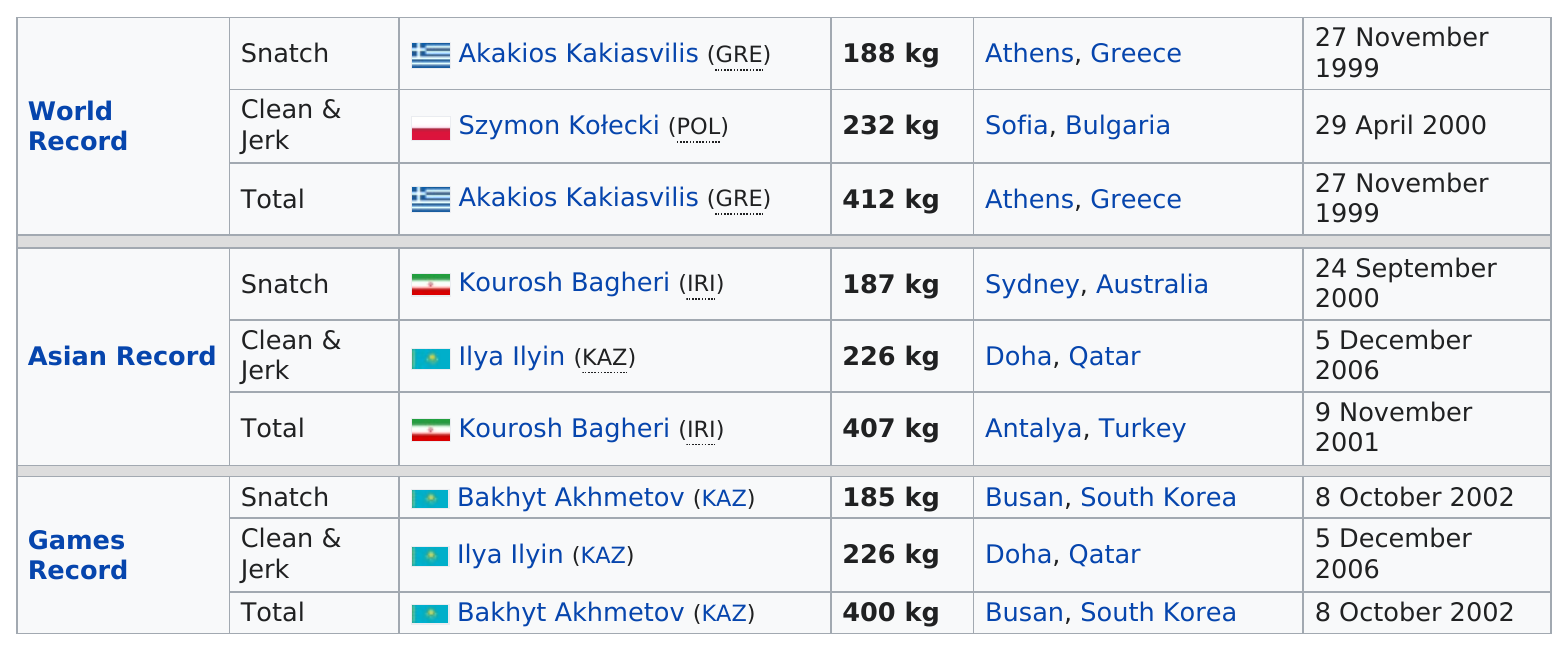Highlight a few significant elements in this photo. The world record for the snatch was either below or above 190 kg. It is more likely that a person named IIya Il'yin has a life that is less than 180 kg. The world record in clean and jerk is 232 kg. Ilya Ilyin of Kazakhstan holds the games and Asian records for the clean & jerk. There is one Polish national who holds a world record. 